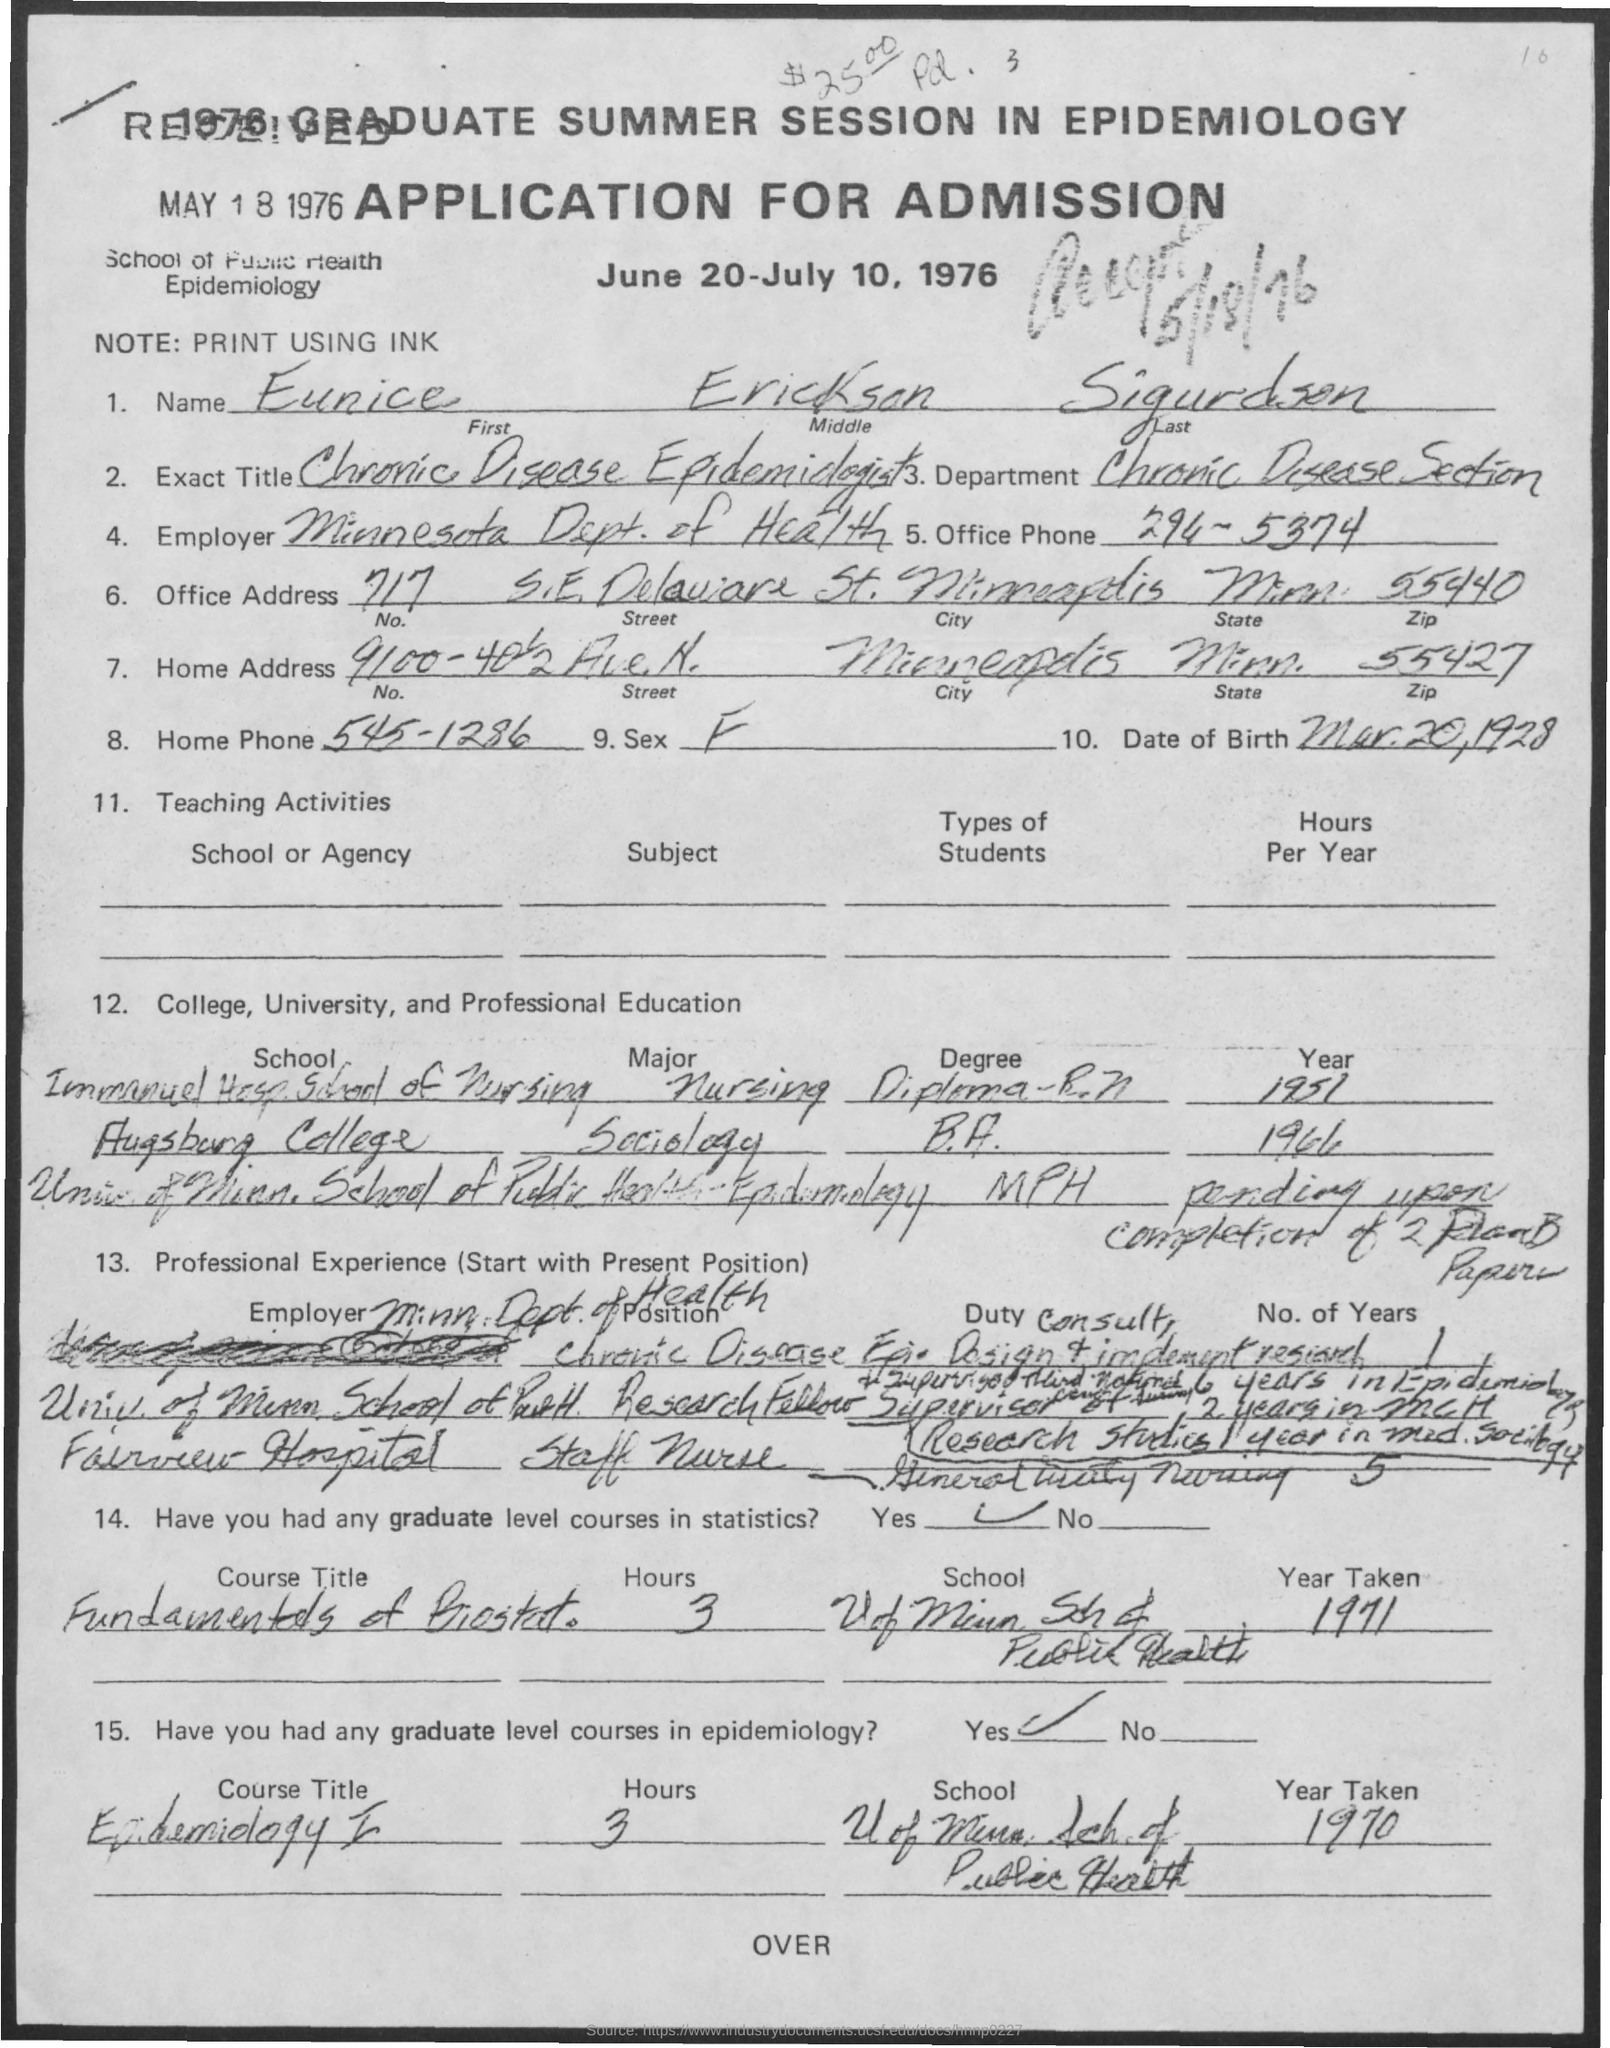What is the First Name of the applicant given here?
Provide a succinct answer. Eunice. What is the exact title of Eunice Erickson Sigurdson?
Offer a very short reply. Chronic Disease Epidemiologist. In Which department, Eunice Erickson Sigurdson works?
Provide a succinct answer. Chronic Disease Section. Who is the current employer of  Eunice Erickson Sigurdson?
Ensure brevity in your answer.  Minnesota Dept. of Health. What is the Office Phone no mentioned in the application?
Your answer should be very brief. 294-5374. What is the zipcode mentioned in the home address?
Provide a short and direct response. 55427. When is this application accepted?
Your answer should be very brief. MAY 18 1976. 